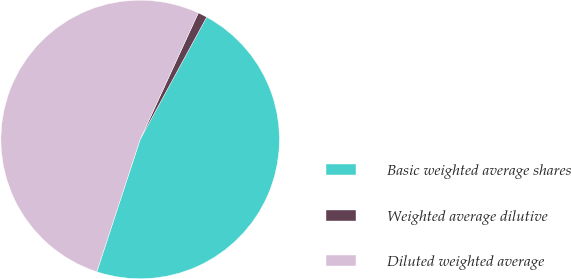<chart> <loc_0><loc_0><loc_500><loc_500><pie_chart><fcel>Basic weighted average shares<fcel>Weighted average dilutive<fcel>Diluted weighted average<nl><fcel>47.11%<fcel>1.07%<fcel>51.82%<nl></chart> 